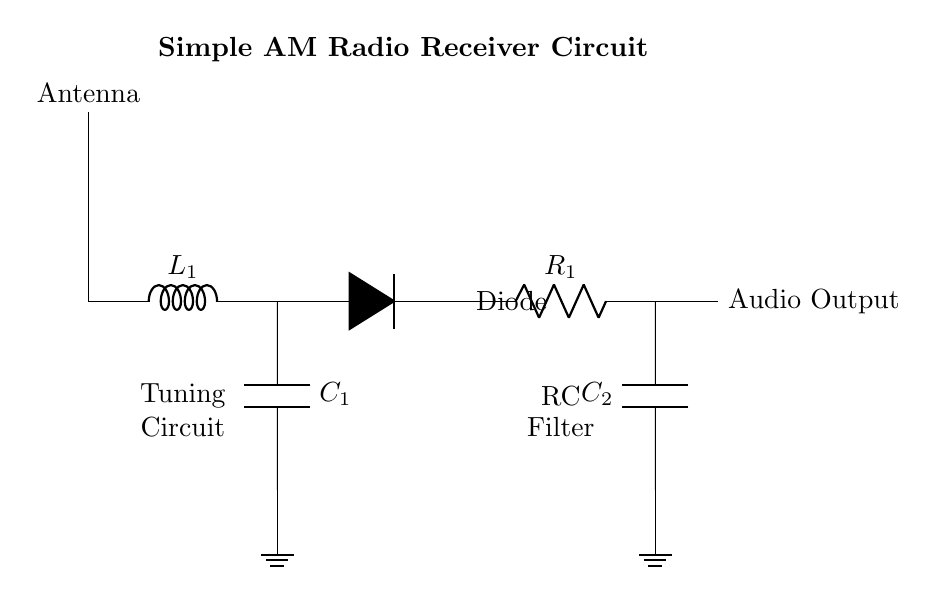What is the function of the diode in this circuit? The diode's function in the circuit is to rectify the AC signal, converting it into a DC signal that can be used for audio output. This is crucial in AM radio receivers where the RF signal needs to be demodulated to produce sound.
Answer: Rectification What component is used for tuning? The tuning circuit consists of an inductor and a capacitor, which are used to select the desired frequency of the incoming signal from the antenna. By varying either of these components, we can tune into different radio stations.
Answer: Inductor and capacitor What is the purpose of the RC filter? The RC filter smooths out the rectified signal from the diode, filtering out high-frequency noise and providing a clearer audio output. It achieves this by allowing low-frequency signals (like audio) to pass while attenuating higher-frequency components.
Answer: Smoothing audio signals How many capacitors are present in the circuit? There are two capacitors present in the circuit; one in the tuning circuit and the other in the RC filter section. Each capacitor serves a specific function related to frequency selection and signal filtering.
Answer: Two What is the audio output connected to? The audio output is connected to the component coming after the RC filter, which is where the processed audio signal can be sent to a speaker or headphone for sound reproduction.
Answer: Speaker or headphone What do the labels L and C stand for denoting the components? The label L stands for the inductance value and denotes the inductor component used in the tuning circuit, and C stands for the capacitance value, representing the capacitors used in the tuning and filtering sections of the circuit.
Answer: Inductor and capacitor What does the ground symbol indicate in the circuit? The ground symbol indicates the reference point for the circuit, which is considered as zero potential. It provides a common return path for the current and stabilizes the circuit operation.
Answer: Reference point for current 